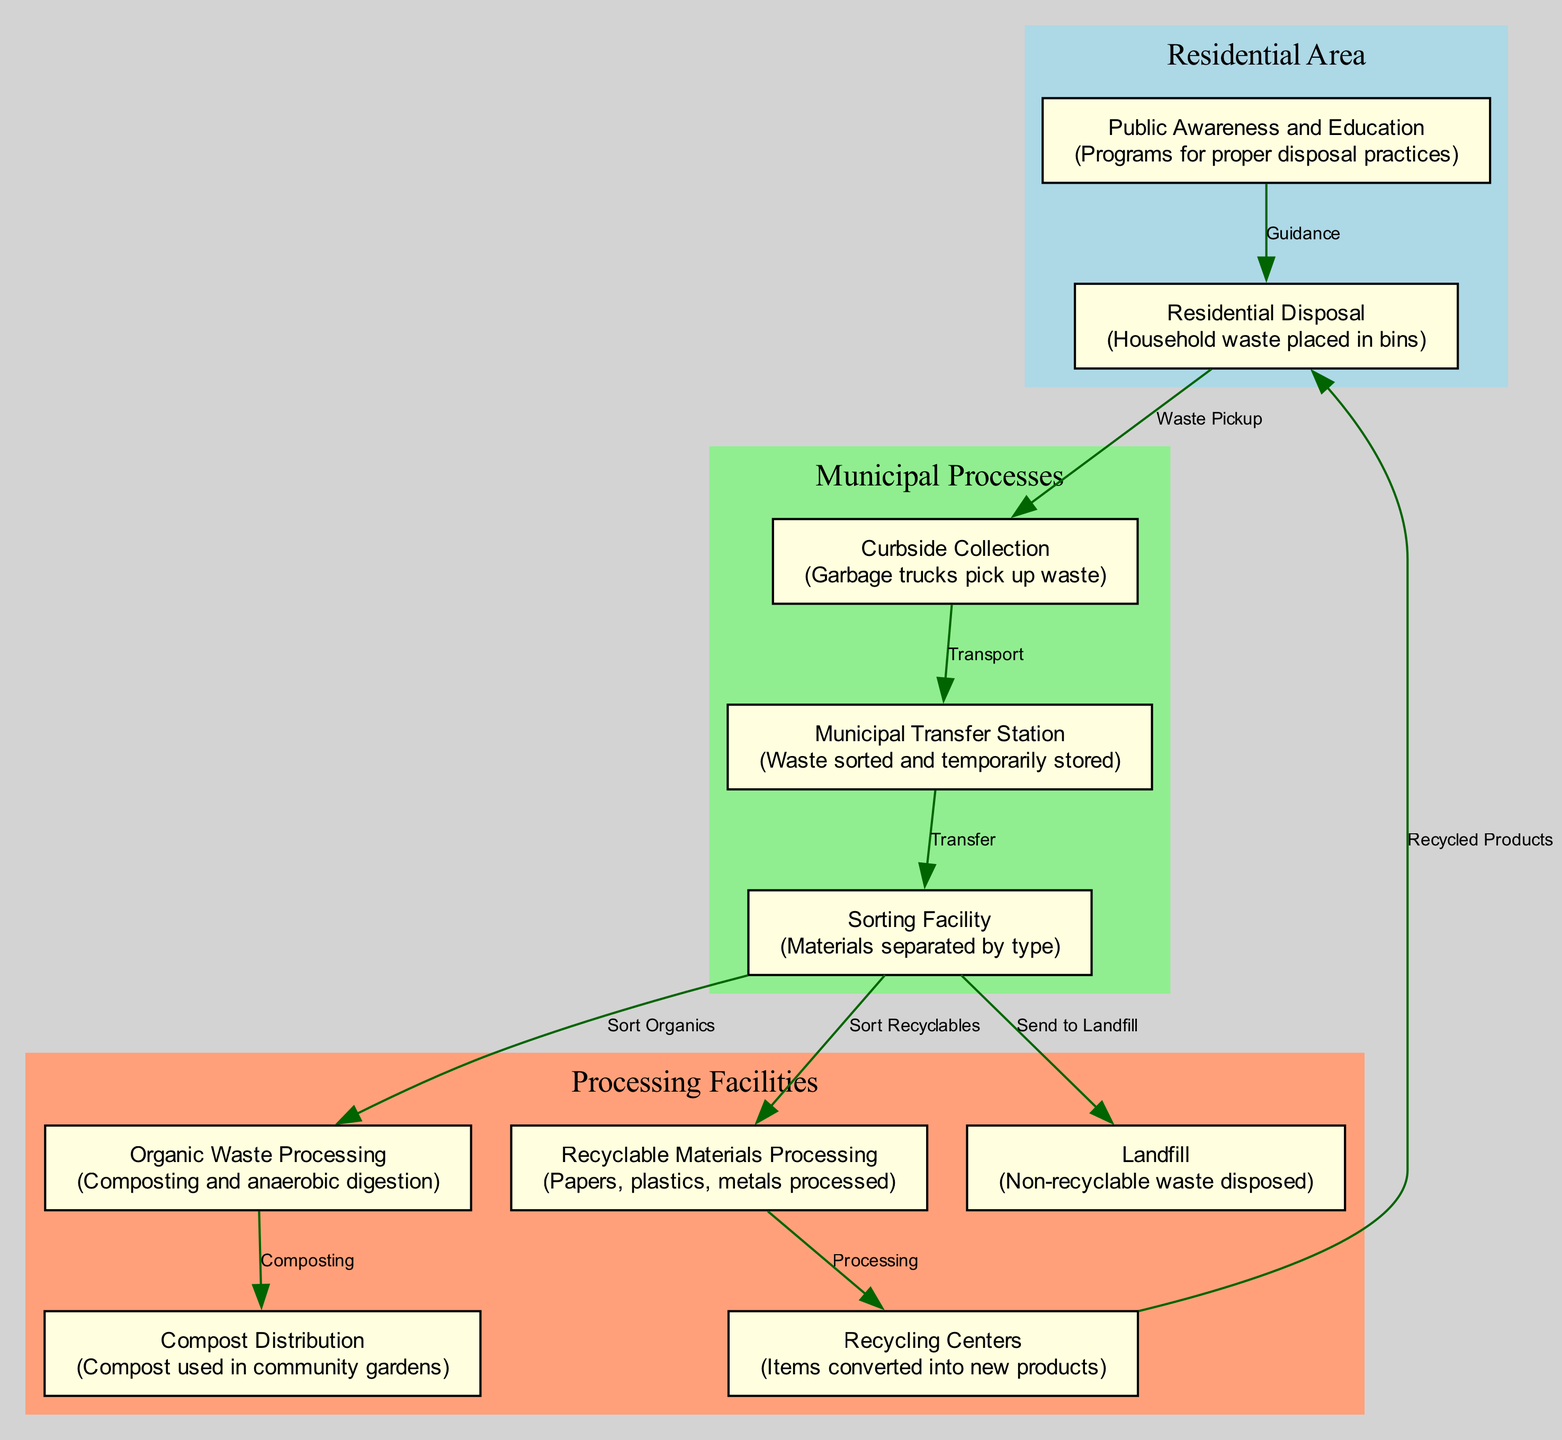What is the first step in the waste management process? The first node in the diagram is "Residential Disposal," which indicates that household waste is placed in bins. This is the starting point of the waste management process.
Answer: Residential Disposal How many nodes are present in the diagram? The diagram contains a total of 10 distinct nodes representing different stages of the waste management process, as listed in the data.
Answer: 10 What happens after the waste is picked up by garbage trucks? According to the flowchart, after the waste is collected through curbside collection, it is transported to the "Municipal Transfer Station," where sorting and temporary storage occur.
Answer: Municipal Transfer Station Which node is responsible for sorting recyclable materials? The "Sorting Facility" is specifically responsible for separating materials by type, which includes both organic waste and recyclables. A specific edge indicates that recyclables are sorted from the sorting facility.
Answer: Sorting Facility What type of waste is sent directly to the landfill? The diagram shows that non-recyclable waste, after being sorted at the sorting facility, is directed to the landfill based on the corresponding connection.
Answer: Non-recyclable waste Describe the relationship between the sorting facility and the compost distribution. The sorting facility sorts organic waste, which then undergoes processing at "Organic Waste Processing," leading to compost that can be distributed and used in community gardens, as indicated by sequential flow.
Answer: Sorting Facility -> Organic Waste Processing -> Compost Distribution What educational role is highlighted in the diagram? The diagram emphasizes the role of "Public Awareness and Education," which involves programs aimed at improving proper disposal practices in the community, supporting sustainable waste management.
Answer: Public Awareness and Education How do recycled materials re-enter the community? After processing at the recycling centers, the recycled materials are transformed into new products, which eventually find their way back to the residential area, highlighting the cycle of recycling.
Answer: Recycled Products What processing occurs specifically for organic waste? The flowchart specifies that organic waste is processed through composting and anaerobic digestion, ensuring that it is effectively transformed into compost for community use.
Answer: Composting and anaerobic digestion 